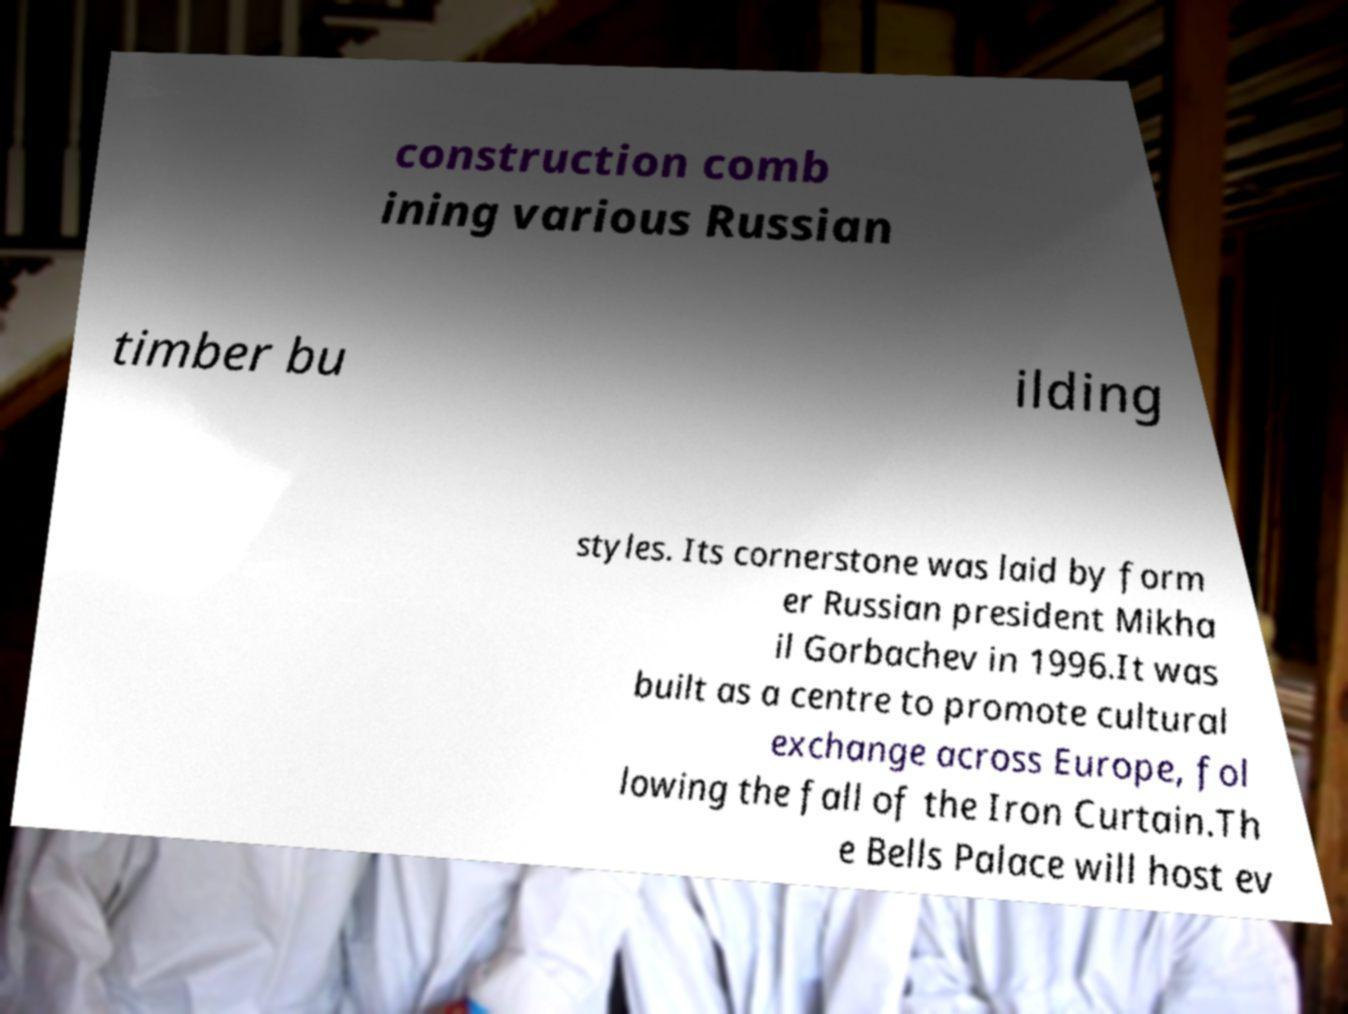What messages or text are displayed in this image? I need them in a readable, typed format. construction comb ining various Russian timber bu ilding styles. Its cornerstone was laid by form er Russian president Mikha il Gorbachev in 1996.It was built as a centre to promote cultural exchange across Europe, fol lowing the fall of the Iron Curtain.Th e Bells Palace will host ev 